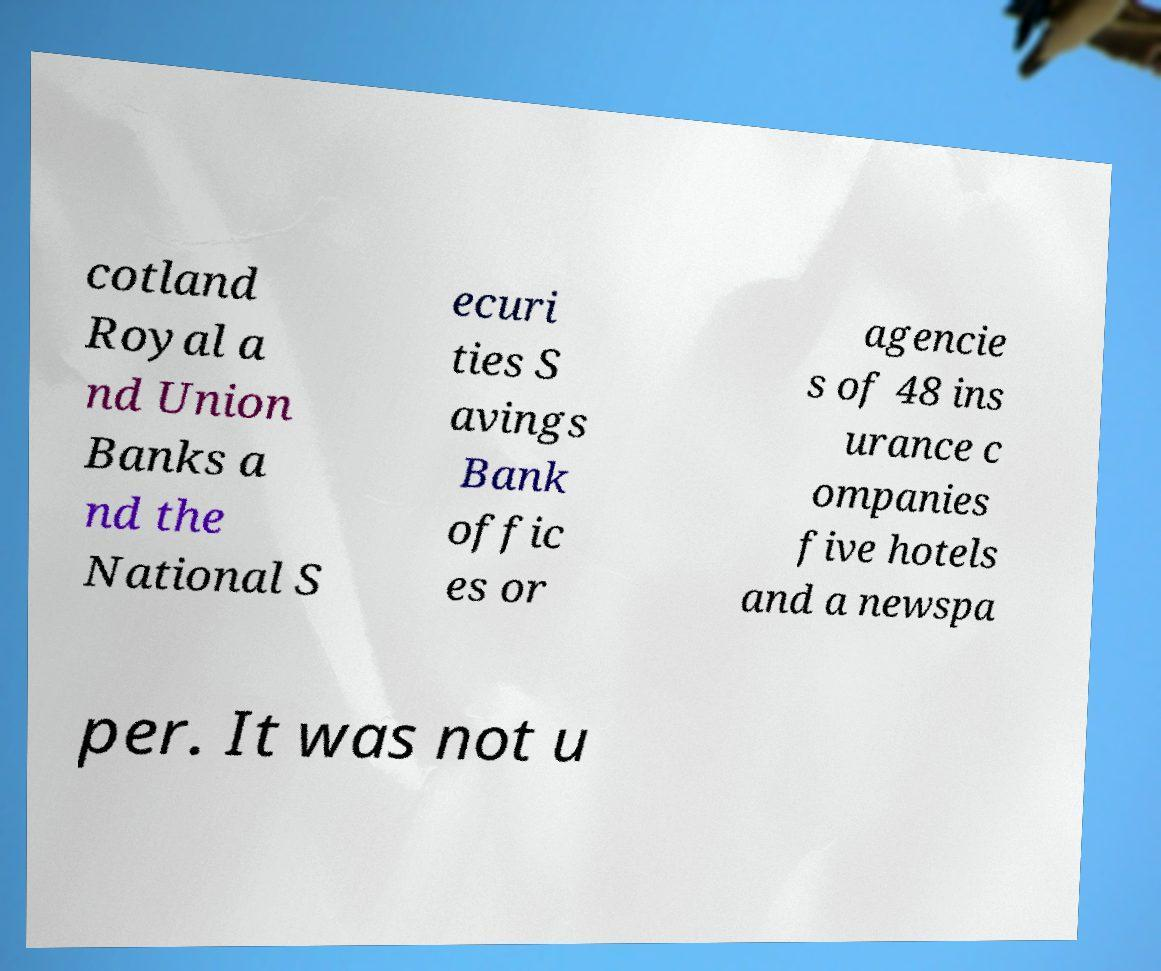For documentation purposes, I need the text within this image transcribed. Could you provide that? cotland Royal a nd Union Banks a nd the National S ecuri ties S avings Bank offic es or agencie s of 48 ins urance c ompanies five hotels and a newspa per. It was not u 